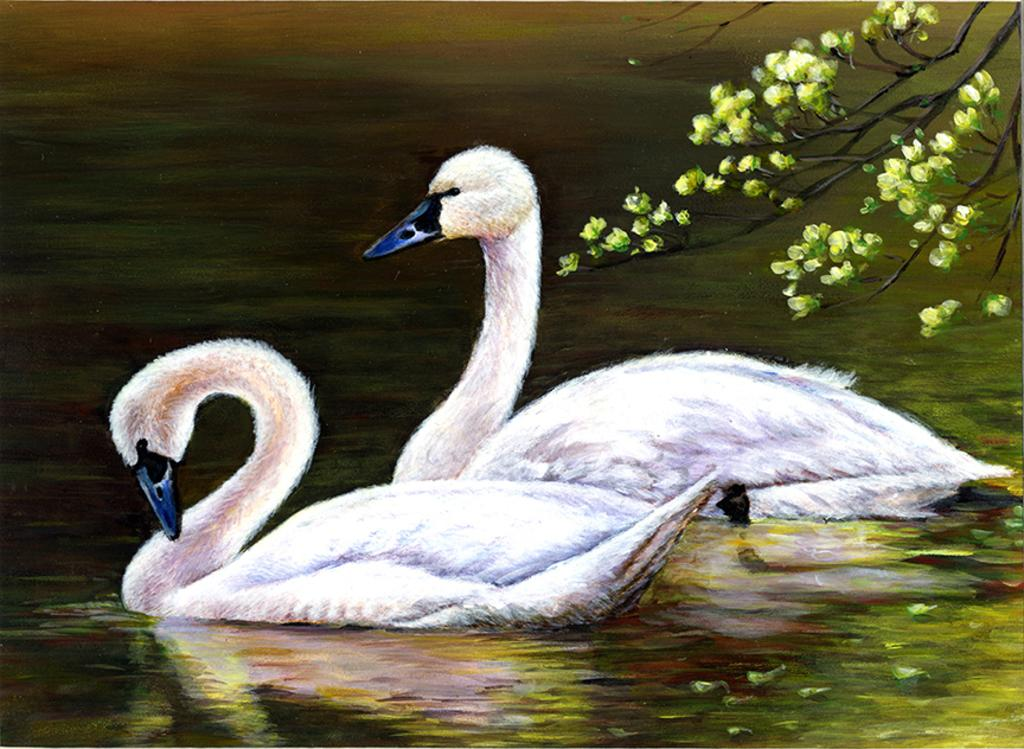What animals can be seen in the image? There are two swans in the image. Where are the swans located? The swans are in the water. What can be seen in the background of the image? There are trees visible in the image. How does the beginner swan learn to attack in the image? There is no indication in the image that any swan is a beginner or learning to attack. 